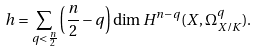<formula> <loc_0><loc_0><loc_500><loc_500>h = \sum _ { q < \frac { n } { 2 } } \left ( \frac { n } { 2 } - q \right ) \dim H ^ { n - q } ( X , \Omega ^ { q } _ { X / K } ) .</formula> 